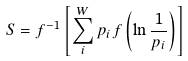Convert formula to latex. <formula><loc_0><loc_0><loc_500><loc_500>S = f ^ { - 1 } \left [ \sum _ { i } ^ { W } p _ { i } f \left ( \ln \frac { 1 } { p _ { i } } \right ) \right ]</formula> 